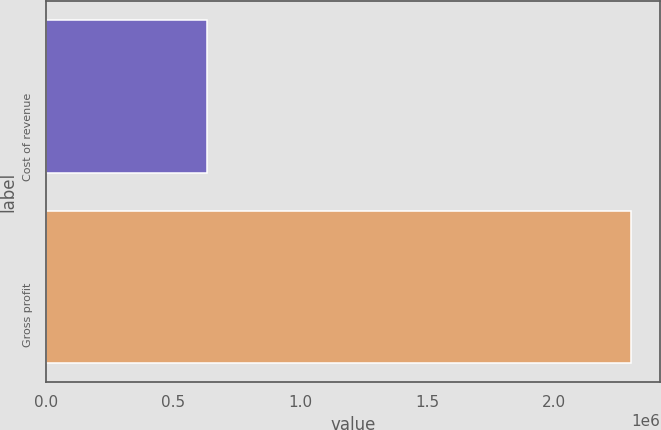<chart> <loc_0><loc_0><loc_500><loc_500><bar_chart><fcel>Cost of revenue<fcel>Gross profit<nl><fcel>634744<fcel>2.30227e+06<nl></chart> 